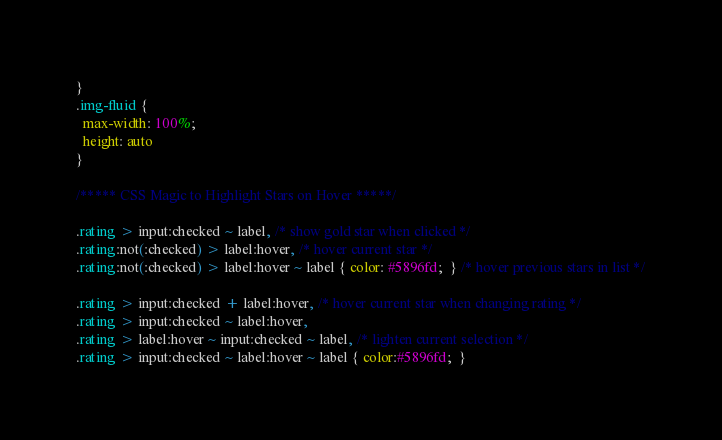<code> <loc_0><loc_0><loc_500><loc_500><_CSS_>}
.img-fluid {
  max-width: 100%;
  height: auto
}

/***** CSS Magic to Highlight Stars on Hover *****/

.rating > input:checked ~ label, /* show gold star when clicked */
.rating:not(:checked) > label:hover, /* hover current star */
.rating:not(:checked) > label:hover ~ label { color: #5896fd;  } /* hover previous stars in list */

.rating > input:checked + label:hover, /* hover current star when changing rating */
.rating > input:checked ~ label:hover,
.rating > label:hover ~ input:checked ~ label, /* lighten current selection */
.rating > input:checked ~ label:hover ~ label { color:#5896fd;  } </code> 